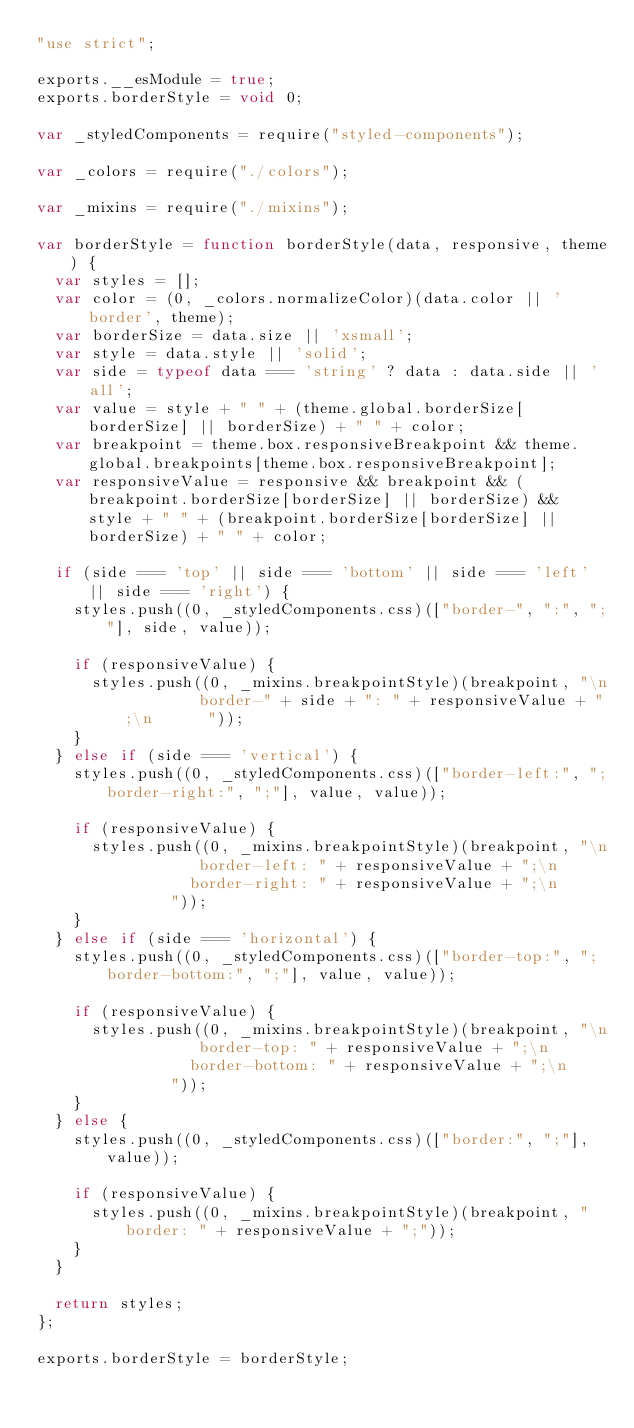Convert code to text. <code><loc_0><loc_0><loc_500><loc_500><_JavaScript_>"use strict";

exports.__esModule = true;
exports.borderStyle = void 0;

var _styledComponents = require("styled-components");

var _colors = require("./colors");

var _mixins = require("./mixins");

var borderStyle = function borderStyle(data, responsive, theme) {
  var styles = [];
  var color = (0, _colors.normalizeColor)(data.color || 'border', theme);
  var borderSize = data.size || 'xsmall';
  var style = data.style || 'solid';
  var side = typeof data === 'string' ? data : data.side || 'all';
  var value = style + " " + (theme.global.borderSize[borderSize] || borderSize) + " " + color;
  var breakpoint = theme.box.responsiveBreakpoint && theme.global.breakpoints[theme.box.responsiveBreakpoint];
  var responsiveValue = responsive && breakpoint && (breakpoint.borderSize[borderSize] || borderSize) && style + " " + (breakpoint.borderSize[borderSize] || borderSize) + " " + color;

  if (side === 'top' || side === 'bottom' || side === 'left' || side === 'right') {
    styles.push((0, _styledComponents.css)(["border-", ":", ";"], side, value));

    if (responsiveValue) {
      styles.push((0, _mixins.breakpointStyle)(breakpoint, "\n        border-" + side + ": " + responsiveValue + ";\n      "));
    }
  } else if (side === 'vertical') {
    styles.push((0, _styledComponents.css)(["border-left:", ";border-right:", ";"], value, value));

    if (responsiveValue) {
      styles.push((0, _mixins.breakpointStyle)(breakpoint, "\n        border-left: " + responsiveValue + ";\n        border-right: " + responsiveValue + ";\n      "));
    }
  } else if (side === 'horizontal') {
    styles.push((0, _styledComponents.css)(["border-top:", ";border-bottom:", ";"], value, value));

    if (responsiveValue) {
      styles.push((0, _mixins.breakpointStyle)(breakpoint, "\n        border-top: " + responsiveValue + ";\n        border-bottom: " + responsiveValue + ";\n      "));
    }
  } else {
    styles.push((0, _styledComponents.css)(["border:", ";"], value));

    if (responsiveValue) {
      styles.push((0, _mixins.breakpointStyle)(breakpoint, "border: " + responsiveValue + ";"));
    }
  }

  return styles;
};

exports.borderStyle = borderStyle;</code> 